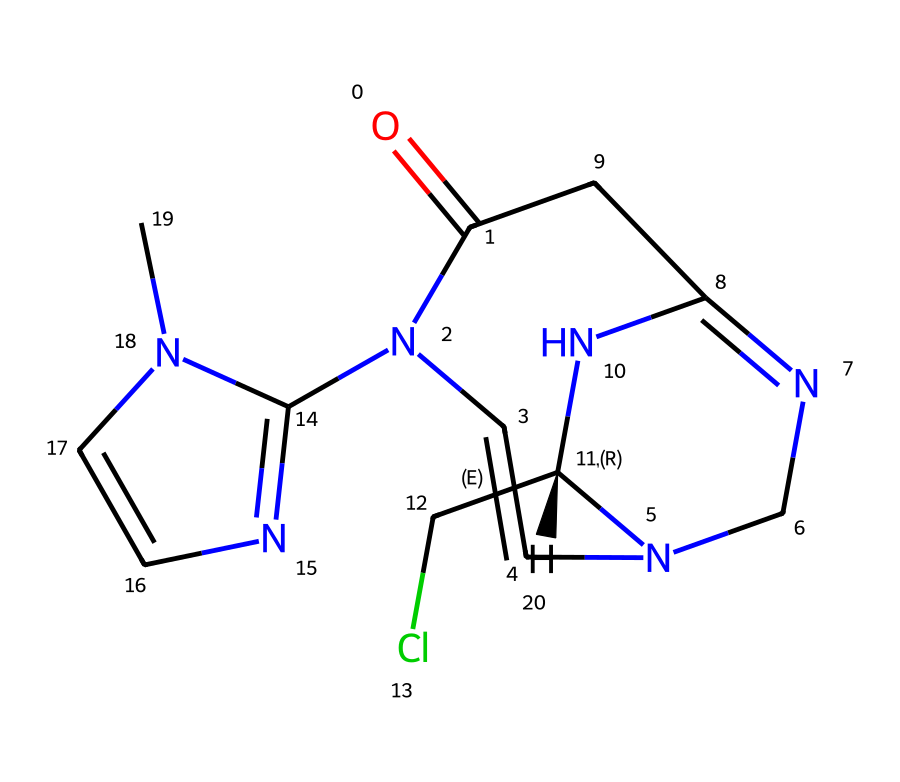What is the molecular formula of this compound? To find the molecular formula, count the number of each type of atom in the SMILES representation. The structure indicates there are 10 carbon (C), 12 hydrogen (H), 4 nitrogen (N), 2 chlorine (Cl), and 1 oxygen (O) atom. Combining these gives the formula C10H12ClN4O.
Answer: C10H12ClN4O How many nitrogen atoms are present? By examining the SMILES, you can see there are four 'N' notations, indicating the presence of four nitrogen atoms in the structure.
Answer: 4 What is the functional group indicated by the 'O=' in the structure? The 'O=' indicates a carbonyl group (C=O), which is a functional group. This is an important feature often linked to biological activity in pharmacological compounds.
Answer: carbonyl group Which part of the molecule suggests that the compound is a neonicotinoid? The presence of a 6-membered nitrogen-containing heterocycle, combined with the structural characteristics derived from the imidazolidine nitrogen atoms in the SMILES representation, is indicative of the neonicotinoid class, which is known for its insecticidal properties and neurotoxic effects on pests.
Answer: 6-membered nitrogen-containing heterocycle How many rings are present in this chemical structure? Analyzing the structure reveals one six-membered ring and another five-membered ring in the molecule, thus, there are a total of two rings in the compound.
Answer: 2 What types of bonds connect the nitrogen atoms in the structure? Reviewing the SMILES representation shows that the nitrogen atoms are connected via double and single bonds, specifically the N=N (double bond) and N-C (single bond) connections. This indicates varying degrees of saturation and can influence chemical reactivity.
Answer: single and double bonds 